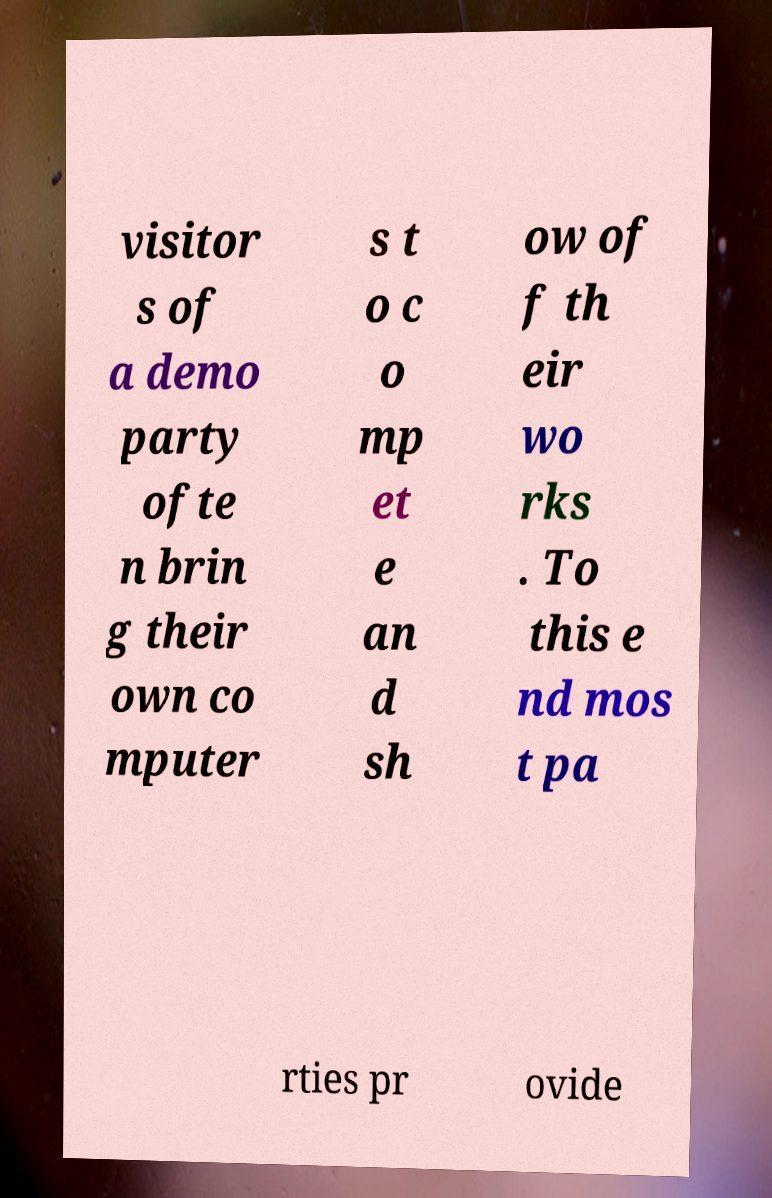What messages or text are displayed in this image? I need them in a readable, typed format. visitor s of a demo party ofte n brin g their own co mputer s t o c o mp et e an d sh ow of f th eir wo rks . To this e nd mos t pa rties pr ovide 